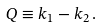<formula> <loc_0><loc_0><loc_500><loc_500>Q \equiv k _ { 1 } - k _ { 2 } \, .</formula> 